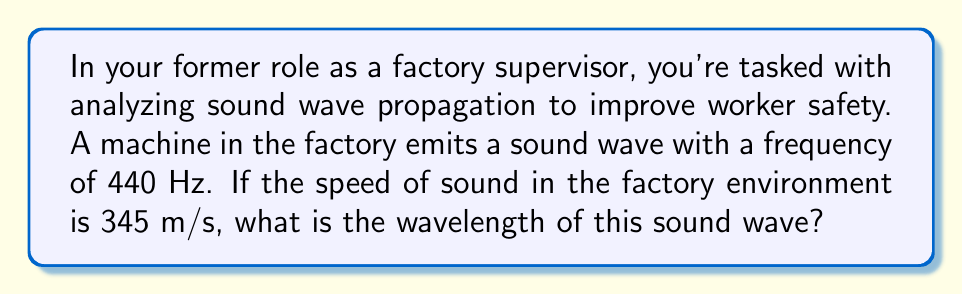Can you solve this math problem? To solve this problem, we'll use the wave equation that relates wave speed, frequency, and wavelength:

$$v = f \lambda$$

Where:
$v$ = wave speed (m/s)
$f$ = frequency (Hz)
$\lambda$ = wavelength (m)

We're given:
$v = 345$ m/s
$f = 440$ Hz

Let's substitute these values into the equation and solve for $\lambda$:

$$345 = 440 \lambda$$

Now, we can isolate $\lambda$:

$$\lambda = \frac{345}{440}$$

Using a calculator or dividing:

$$\lambda \approx 0.7841 \text{ m}$$

Rounding to three significant figures:

$$\lambda \approx 0.784 \text{ m}$$

This means the sound wave has a wavelength of approximately 0.784 meters or 78.4 centimeters.
Answer: 0.784 m 